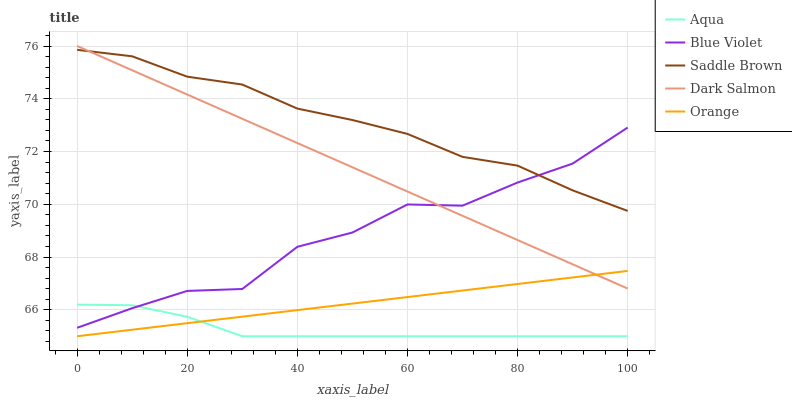Does Aqua have the minimum area under the curve?
Answer yes or no. Yes. Does Saddle Brown have the maximum area under the curve?
Answer yes or no. Yes. Does Saddle Brown have the minimum area under the curve?
Answer yes or no. No. Does Aqua have the maximum area under the curve?
Answer yes or no. No. Is Dark Salmon the smoothest?
Answer yes or no. Yes. Is Blue Violet the roughest?
Answer yes or no. Yes. Is Aqua the smoothest?
Answer yes or no. No. Is Aqua the roughest?
Answer yes or no. No. Does Orange have the lowest value?
Answer yes or no. Yes. Does Saddle Brown have the lowest value?
Answer yes or no. No. Does Dark Salmon have the highest value?
Answer yes or no. Yes. Does Saddle Brown have the highest value?
Answer yes or no. No. Is Aqua less than Dark Salmon?
Answer yes or no. Yes. Is Saddle Brown greater than Orange?
Answer yes or no. Yes. Does Dark Salmon intersect Orange?
Answer yes or no. Yes. Is Dark Salmon less than Orange?
Answer yes or no. No. Is Dark Salmon greater than Orange?
Answer yes or no. No. Does Aqua intersect Dark Salmon?
Answer yes or no. No. 